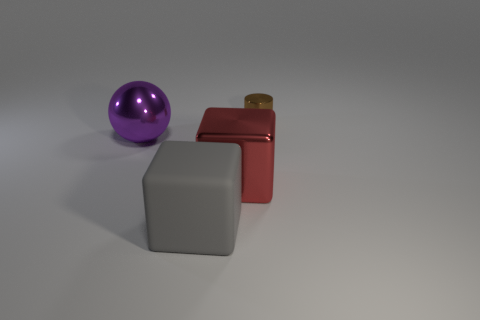Is the number of large balls that are right of the shiny cube less than the number of small metallic things to the right of the brown metallic object?
Your answer should be very brief. No. What is the shape of the large metallic thing that is behind the big shiny object in front of the large metallic object on the left side of the gray rubber block?
Provide a short and direct response. Sphere. What shape is the metallic thing that is both on the right side of the big purple thing and in front of the small metal cylinder?
Your answer should be compact. Cube. Are there any other cubes made of the same material as the large gray block?
Provide a short and direct response. No. There is a large cube to the right of the large gray matte cube; what color is it?
Keep it short and to the point. Red. Does the big rubber object have the same shape as the large shiny thing that is on the right side of the shiny ball?
Your response must be concise. Yes. Is there a small matte cylinder of the same color as the large sphere?
Provide a succinct answer. No. The block that is the same material as the brown cylinder is what size?
Your answer should be very brief. Large. Is the tiny shiny cylinder the same color as the large rubber block?
Ensure brevity in your answer.  No. Does the big shiny object that is behind the big red thing have the same shape as the large gray matte thing?
Offer a terse response. No. 